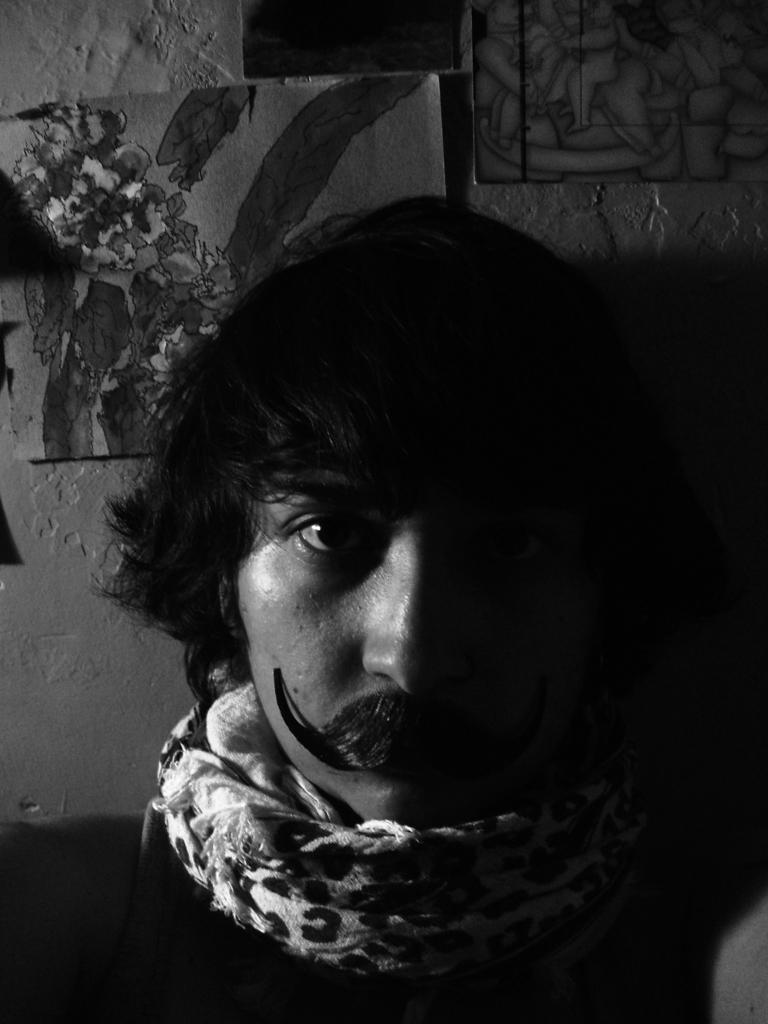Describe this image in one or two sentences. In this image I can see the person. I can see few frames attached to the wall. The image is in black and white color. 